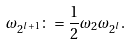Convert formula to latex. <formula><loc_0><loc_0><loc_500><loc_500>\omega _ { 2 ^ { l + 1 } } \colon = \frac { 1 } { 2 } \omega _ { 2 } \omega _ { 2 ^ { l } } .</formula> 